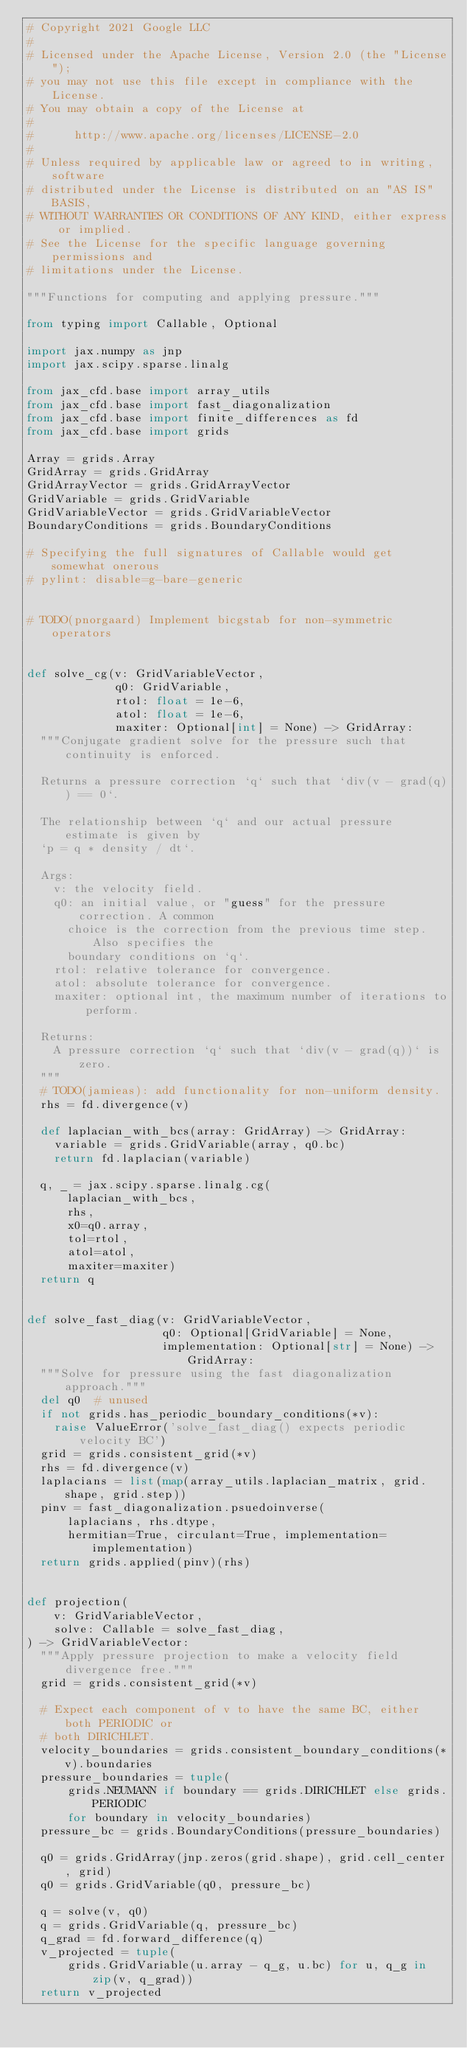<code> <loc_0><loc_0><loc_500><loc_500><_Python_># Copyright 2021 Google LLC
#
# Licensed under the Apache License, Version 2.0 (the "License");
# you may not use this file except in compliance with the License.
# You may obtain a copy of the License at
#
#      http://www.apache.org/licenses/LICENSE-2.0
#
# Unless required by applicable law or agreed to in writing, software
# distributed under the License is distributed on an "AS IS" BASIS,
# WITHOUT WARRANTIES OR CONDITIONS OF ANY KIND, either express or implied.
# See the License for the specific language governing permissions and
# limitations under the License.

"""Functions for computing and applying pressure."""

from typing import Callable, Optional

import jax.numpy as jnp
import jax.scipy.sparse.linalg

from jax_cfd.base import array_utils
from jax_cfd.base import fast_diagonalization
from jax_cfd.base import finite_differences as fd
from jax_cfd.base import grids

Array = grids.Array
GridArray = grids.GridArray
GridArrayVector = grids.GridArrayVector
GridVariable = grids.GridVariable
GridVariableVector = grids.GridVariableVector
BoundaryConditions = grids.BoundaryConditions

# Specifying the full signatures of Callable would get somewhat onerous
# pylint: disable=g-bare-generic


# TODO(pnorgaard) Implement bicgstab for non-symmetric operators


def solve_cg(v: GridVariableVector,
             q0: GridVariable,
             rtol: float = 1e-6,
             atol: float = 1e-6,
             maxiter: Optional[int] = None) -> GridArray:
  """Conjugate gradient solve for the pressure such that continuity is enforced.

  Returns a pressure correction `q` such that `div(v - grad(q)) == 0`.

  The relationship between `q` and our actual pressure estimate is given by
  `p = q * density / dt`.

  Args:
    v: the velocity field.
    q0: an initial value, or "guess" for the pressure correction. A common
      choice is the correction from the previous time step. Also specifies the
      boundary conditions on `q`.
    rtol: relative tolerance for convergence.
    atol: absolute tolerance for convergence.
    maxiter: optional int, the maximum number of iterations to perform.

  Returns:
    A pressure correction `q` such that `div(v - grad(q))` is zero.
  """
  # TODO(jamieas): add functionality for non-uniform density.
  rhs = fd.divergence(v)

  def laplacian_with_bcs(array: GridArray) -> GridArray:
    variable = grids.GridVariable(array, q0.bc)
    return fd.laplacian(variable)

  q, _ = jax.scipy.sparse.linalg.cg(
      laplacian_with_bcs,
      rhs,
      x0=q0.array,
      tol=rtol,
      atol=atol,
      maxiter=maxiter)
  return q


def solve_fast_diag(v: GridVariableVector,
                    q0: Optional[GridVariable] = None,
                    implementation: Optional[str] = None) -> GridArray:
  """Solve for pressure using the fast diagonalization approach."""
  del q0  # unused
  if not grids.has_periodic_boundary_conditions(*v):
    raise ValueError('solve_fast_diag() expects periodic velocity BC')
  grid = grids.consistent_grid(*v)
  rhs = fd.divergence(v)
  laplacians = list(map(array_utils.laplacian_matrix, grid.shape, grid.step))
  pinv = fast_diagonalization.psuedoinverse(
      laplacians, rhs.dtype,
      hermitian=True, circulant=True, implementation=implementation)
  return grids.applied(pinv)(rhs)


def projection(
    v: GridVariableVector,
    solve: Callable = solve_fast_diag,
) -> GridVariableVector:
  """Apply pressure projection to make a velocity field divergence free."""
  grid = grids.consistent_grid(*v)

  # Expect each component of v to have the same BC, either both PERIODIC or
  # both DIRICHLET.
  velocity_boundaries = grids.consistent_boundary_conditions(*v).boundaries
  pressure_boundaries = tuple(
      grids.NEUMANN if boundary == grids.DIRICHLET else grids.PERIODIC
      for boundary in velocity_boundaries)
  pressure_bc = grids.BoundaryConditions(pressure_boundaries)

  q0 = grids.GridArray(jnp.zeros(grid.shape), grid.cell_center, grid)
  q0 = grids.GridVariable(q0, pressure_bc)

  q = solve(v, q0)
  q = grids.GridVariable(q, pressure_bc)
  q_grad = fd.forward_difference(q)
  v_projected = tuple(
      grids.GridVariable(u.array - q_g, u.bc) for u, q_g in zip(v, q_grad))
  return v_projected
</code> 